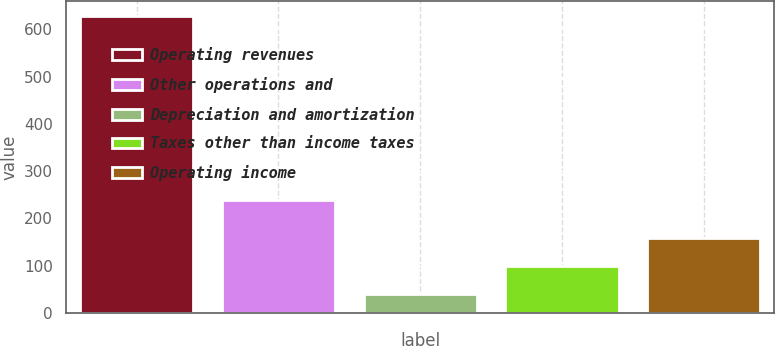Convert chart. <chart><loc_0><loc_0><loc_500><loc_500><bar_chart><fcel>Operating revenues<fcel>Other operations and<fcel>Depreciation and amortization<fcel>Taxes other than income taxes<fcel>Operating income<nl><fcel>628<fcel>238<fcel>41<fcel>99.7<fcel>158.4<nl></chart> 